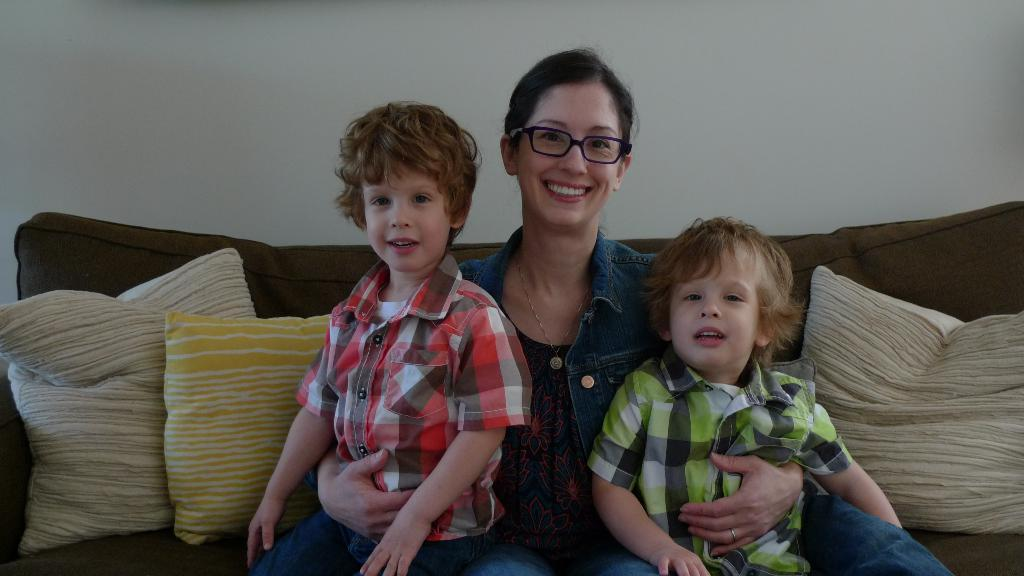How many people are in the image? There are three persons in the image. What are the persons doing in the image? The persons are smiling. Where are the persons sitting in the image? The persons are sitting on a couch. What can be seen on the couch besides the persons? There are pillows in the image. What is visible in the background of the image? There is a wall in the background of the image. What flavor of ice cream are the persons holding in the image? There is no ice cream present in the image; the persons are not holding any ice cream. How many rings can be seen on the persons' elbows in the image? There are no rings visible on the persons' elbows in the image. 